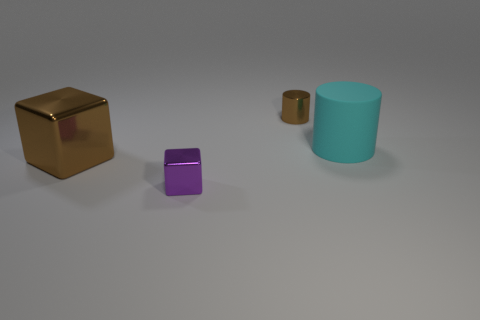Add 1 blue rubber cubes. How many objects exist? 5 Subtract 0 red spheres. How many objects are left? 4 Subtract all purple matte balls. Subtract all tiny brown shiny objects. How many objects are left? 3 Add 2 purple objects. How many purple objects are left? 3 Add 4 large green matte objects. How many large green matte objects exist? 4 